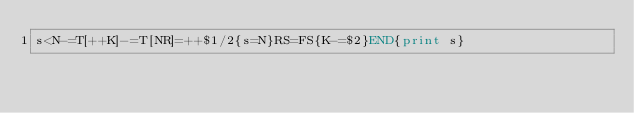<code> <loc_0><loc_0><loc_500><loc_500><_Awk_>s<N-=T[++K]-=T[NR]=++$1/2{s=N}RS=FS{K-=$2}END{print s}</code> 